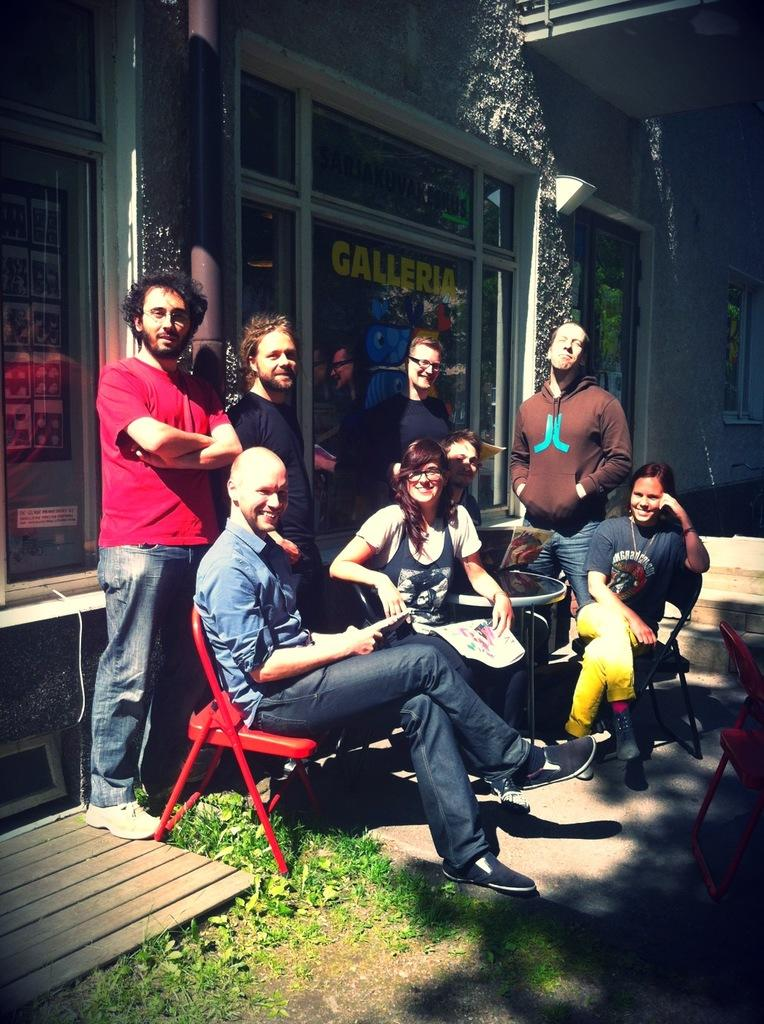How many people are in the image? There is a group of people in the image, but the exact number cannot be determined from the provided facts. What type of furniture is visible in the image? There are chairs and a table visible in the image. What can be seen in the background of the image? There is a building in the background of the image. What type of spark can be seen coming from the knee of the person in the image? There is no spark or any indication of a spark in the image. Additionally, no specific person is mentioned, so it is impossible to determine if any person's knee is visible in the image. 